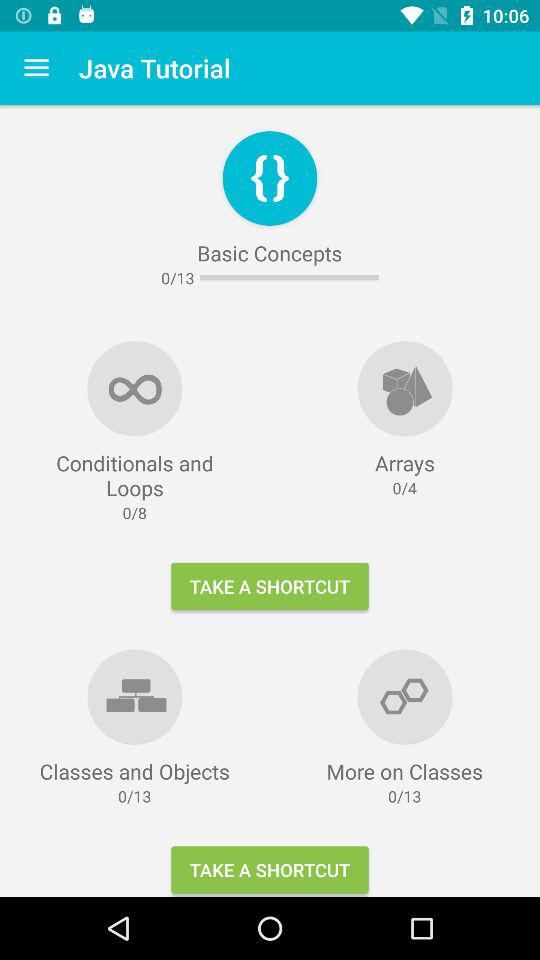What is the app name? The app name is "Java Tutorial". 